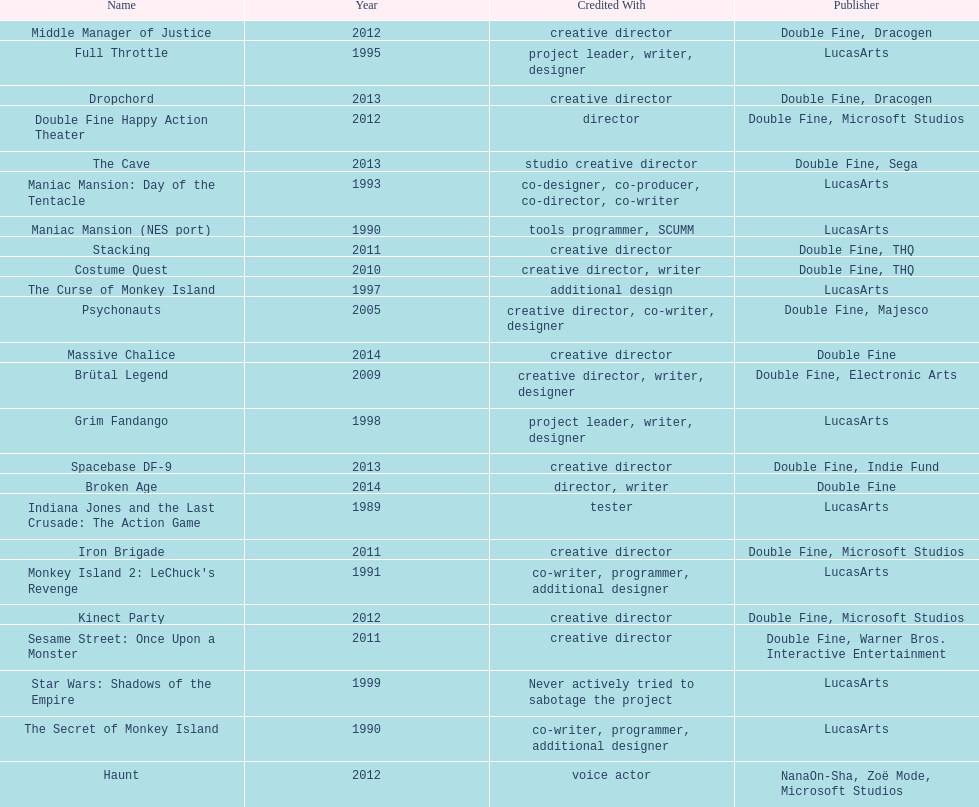Which game is credited with a creative director and warner bros. interactive entertainment as their creative director? Sesame Street: Once Upon a Monster. 